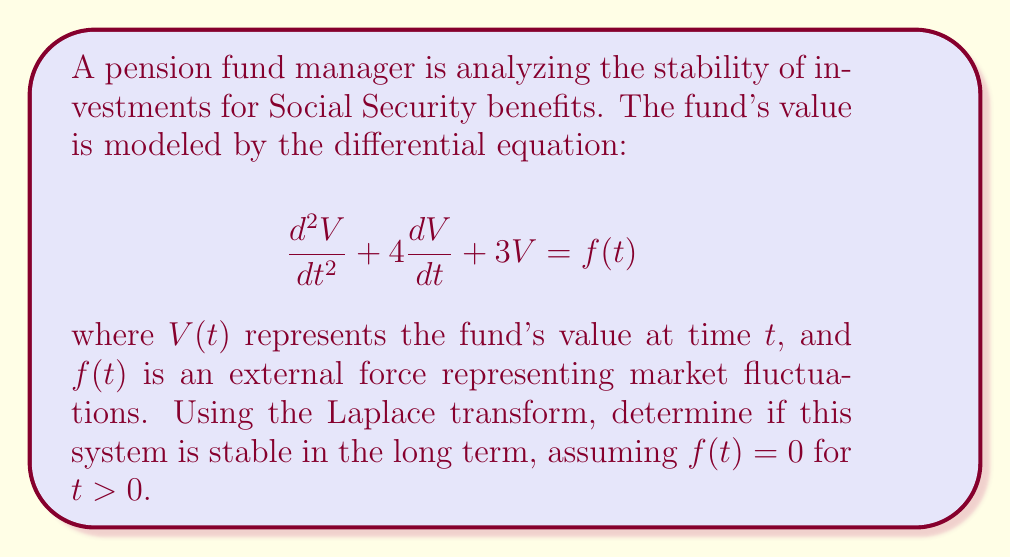Provide a solution to this math problem. To analyze the stability of this system using Laplace transforms, we follow these steps:

1) First, we take the Laplace transform of both sides of the equation, assuming zero initial conditions:

   $$\mathcal{L}\left\{\frac{d^2V}{dt^2} + 4\frac{dV}{dt} + 3V\right\} = \mathcal{L}\{f(t)\}$$

2) Using Laplace transform properties:

   $$s^2V(s) + 4sV(s) + 3V(s) = F(s)$$

3) Factor out $V(s)$:

   $$V(s)(s^2 + 4s + 3) = F(s)$$

4) The transfer function $H(s)$ of the system is:

   $$H(s) = \frac{V(s)}{F(s)} = \frac{1}{s^2 + 4s + 3}$$

5) To determine stability, we need to find the poles of $H(s)$. These are the roots of the characteristic equation:

   $$s^2 + 4s + 3 = 0$$

6) Solving this quadratic equation:

   $$s = \frac{-4 \pm \sqrt{16 - 12}}{2} = \frac{-4 \pm \sqrt{4}}{2} = \frac{-4 \pm 2}{2}$$

7) The roots are:

   $$s_1 = -3 \quad \text{and} \quad s_2 = -1$$

8) For a system to be stable, all poles must have negative real parts. In this case, both poles are real and negative.

Therefore, the system is stable in the long term. This means that any perturbations in the pension fund's value will eventually decay, and the fund will return to its equilibrium state.
Answer: The system is stable in the long term because both poles of the transfer function ($s_1 = -3$ and $s_2 = -1$) have negative real parts. 